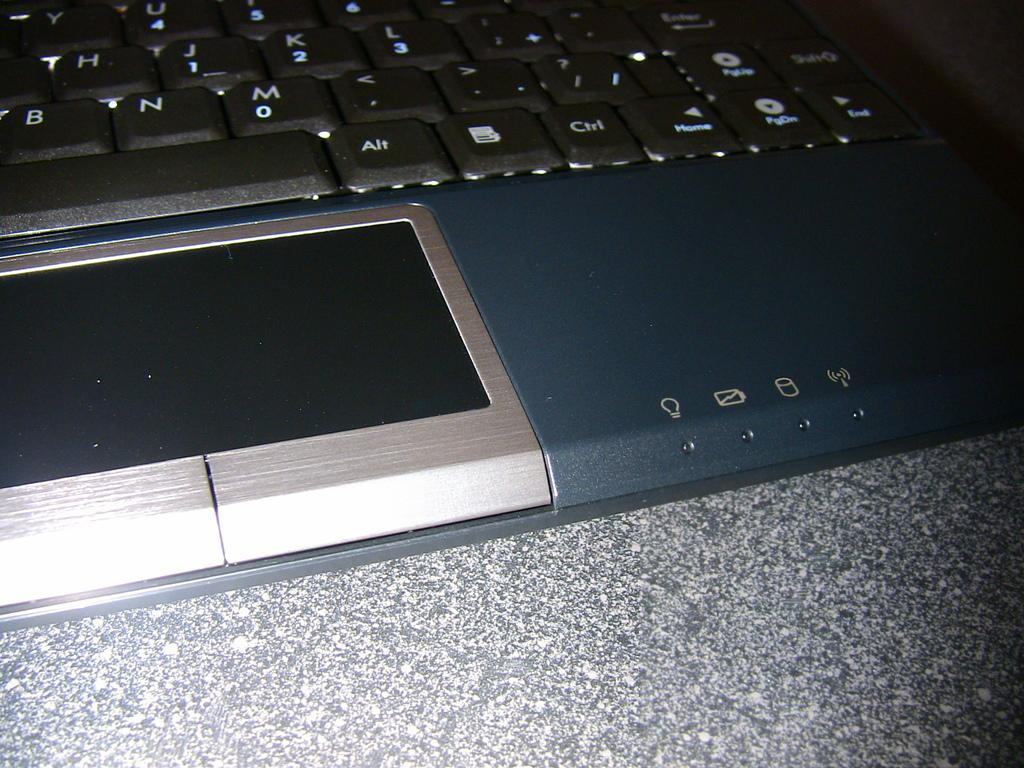<image>
Describe the image concisely. Bottom of a laptop showing the Alt key next to a spacebar key. 